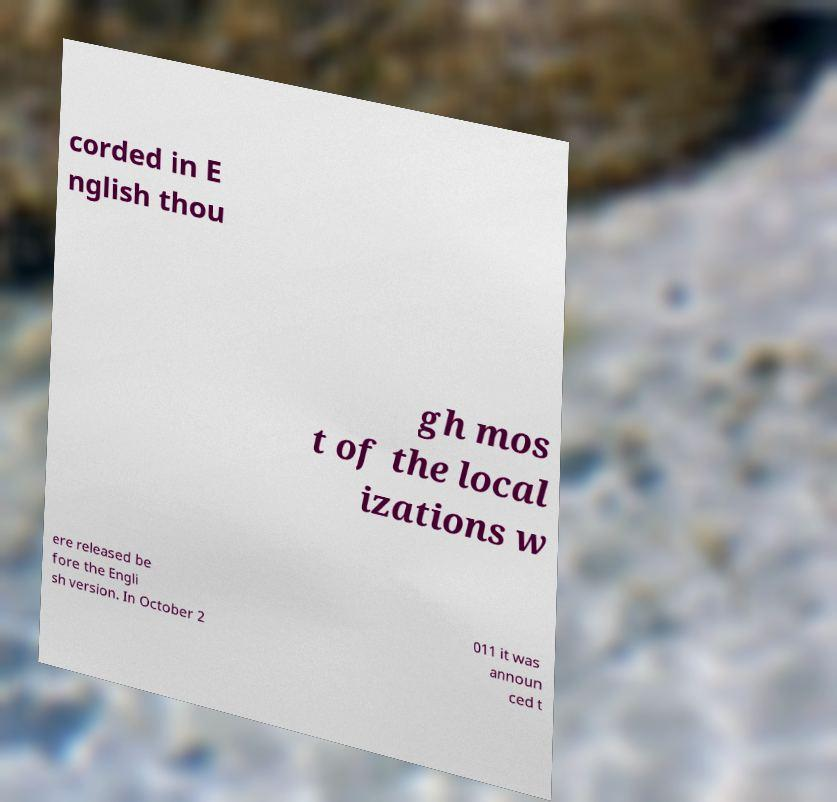Could you assist in decoding the text presented in this image and type it out clearly? corded in E nglish thou gh mos t of the local izations w ere released be fore the Engli sh version. In October 2 011 it was announ ced t 